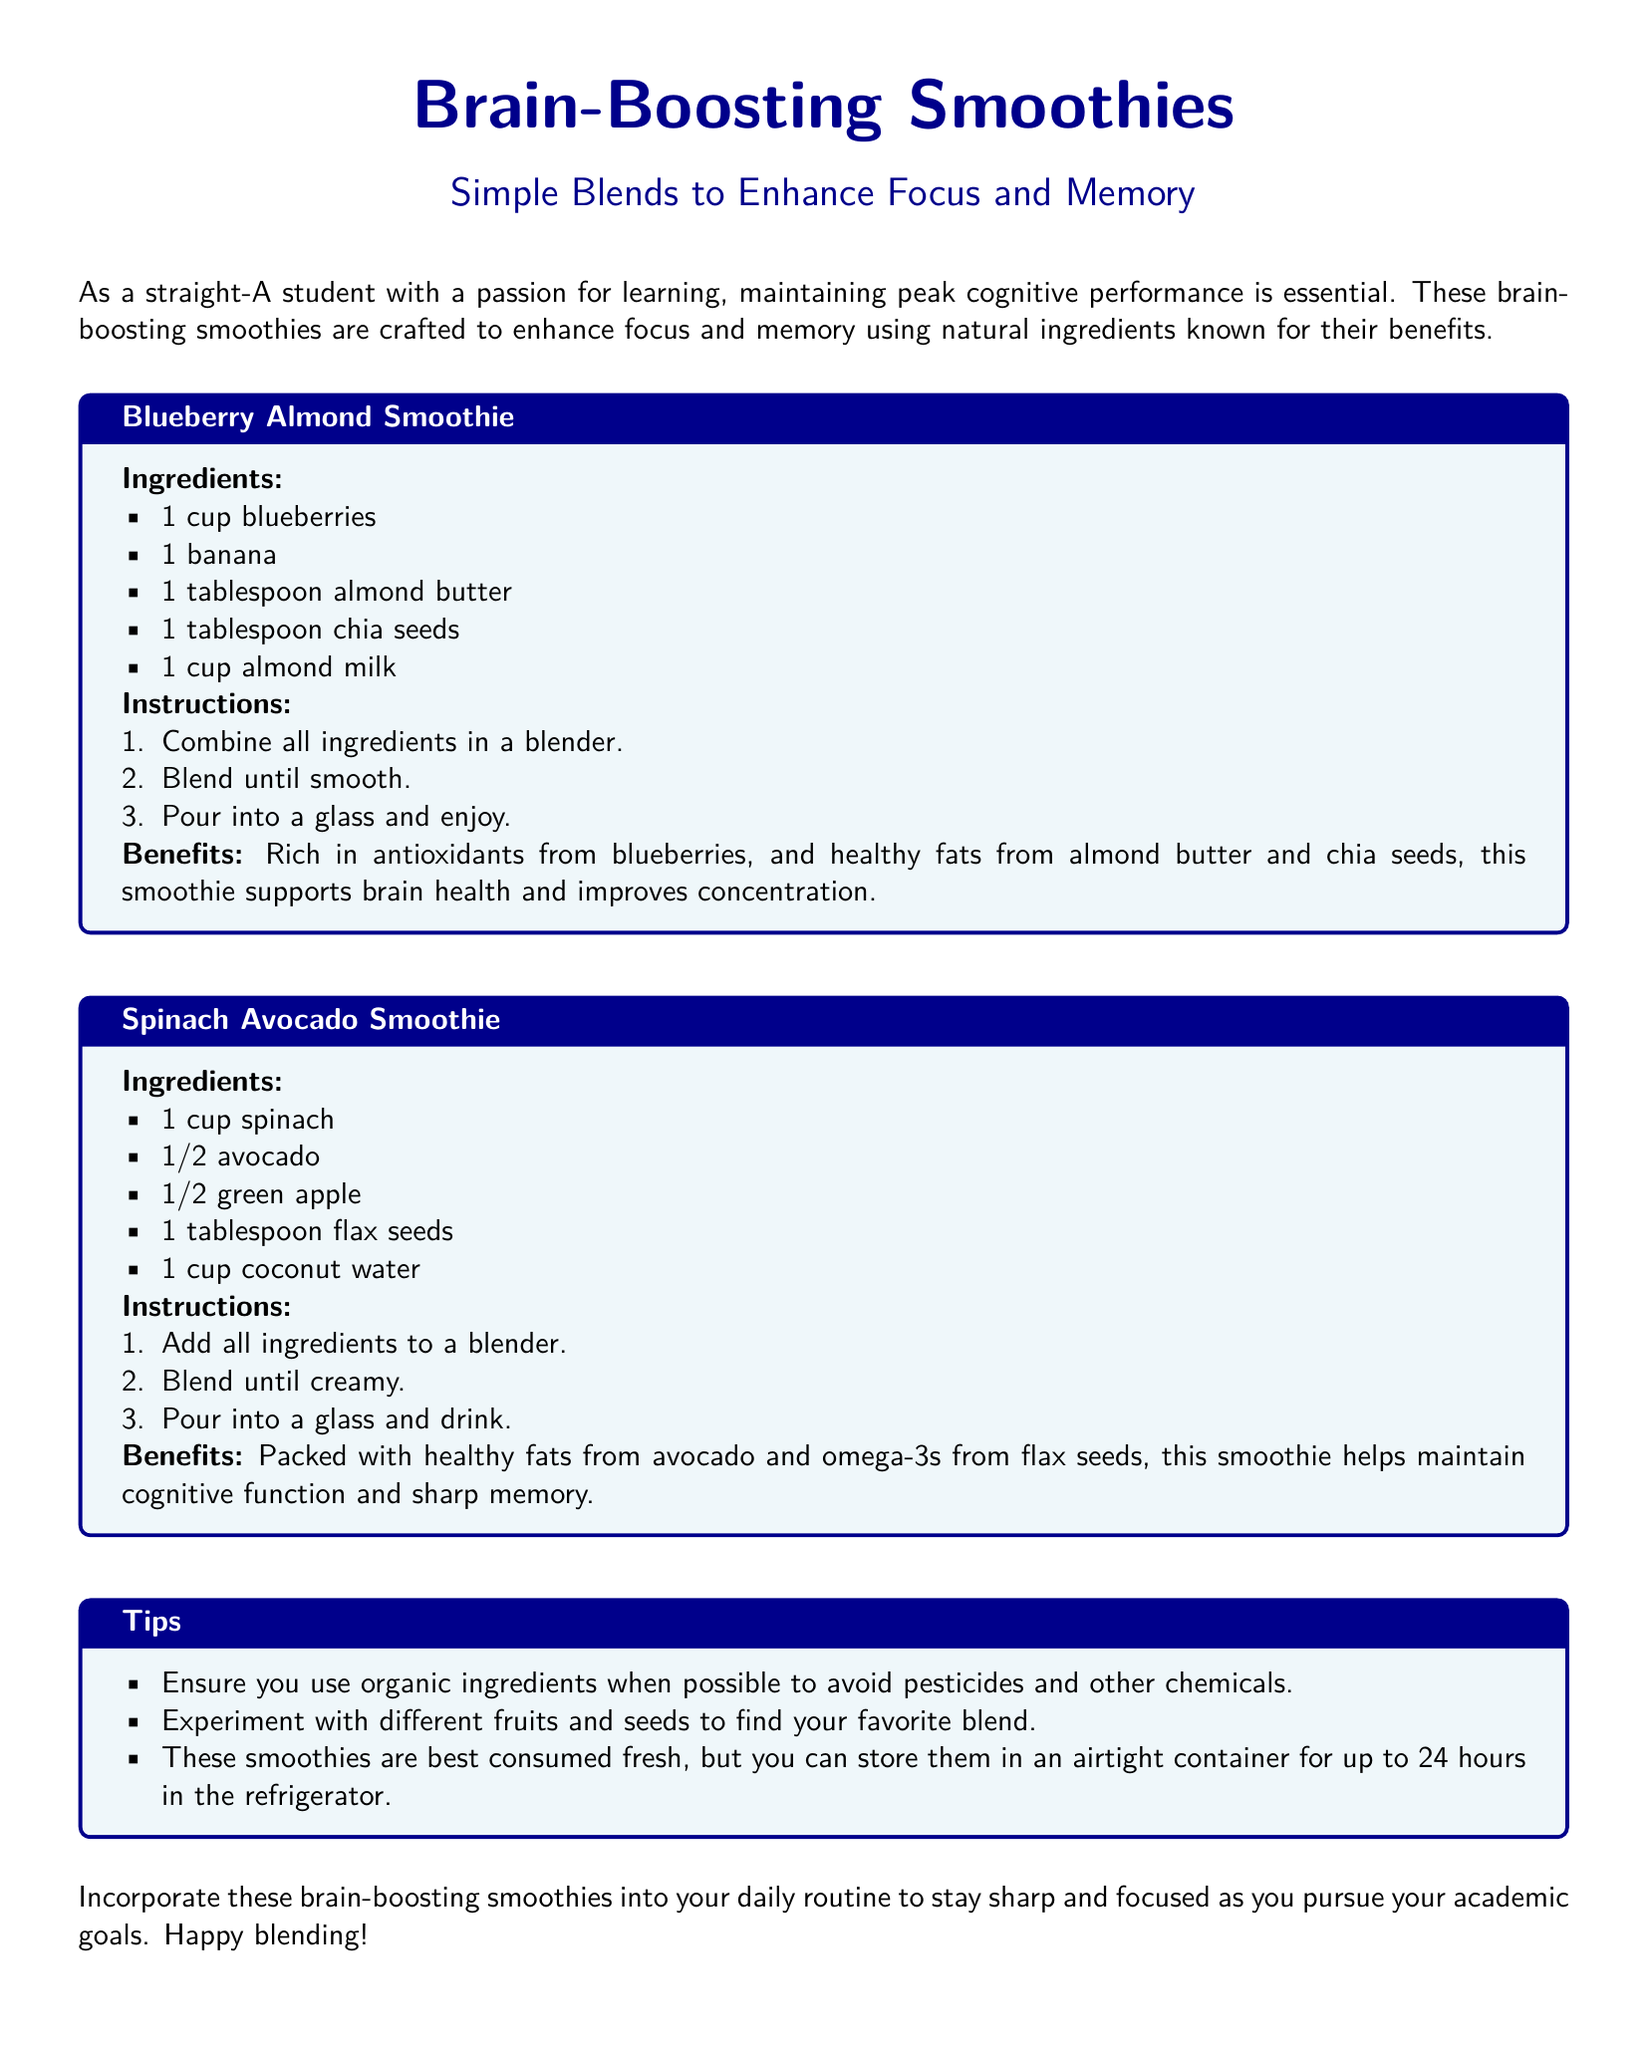What is the title of the document? The title is prominently displayed at the top of the document, stating what the content is about.
Answer: Brain-Boosting Smoothies How many smoothies are provided in the document? The document details two specific smoothies.
Answer: 2 What fruit is included in the Blueberry Almond Smoothie? The Blueberry Almond Smoothie lists blueberries as one of its ingredients.
Answer: Blueberries What is the main benefit mentioned for the Spinach Avocado Smoothie? The document states that the Spinach Avocado Smoothie helps maintain cognitive function and sharp memory.
Answer: Cognitive function and sharp memory What type of seeds can be found in the Blueberry Almond Smoothie? The Blueberry Almond Smoothie includes chia seeds as one of its ingredients.
Answer: Chia seeds How should the smoothies be stored if not consumed immediately? The document advises storing the smoothies in an airtight container to maintain freshness.
Answer: Airtight container for up to 24 hours What is a suggested modification when preparing the smoothies? The document encourages experimenting with different fruits and seeds to customize the recipe.
Answer: Experiment with different fruits and seeds What is the main liquid ingredient in the Spinach Avocado Smoothie? The Spinach Avocado Smoothie specifically lists coconut water as its liquid component.
Answer: Coconut water 